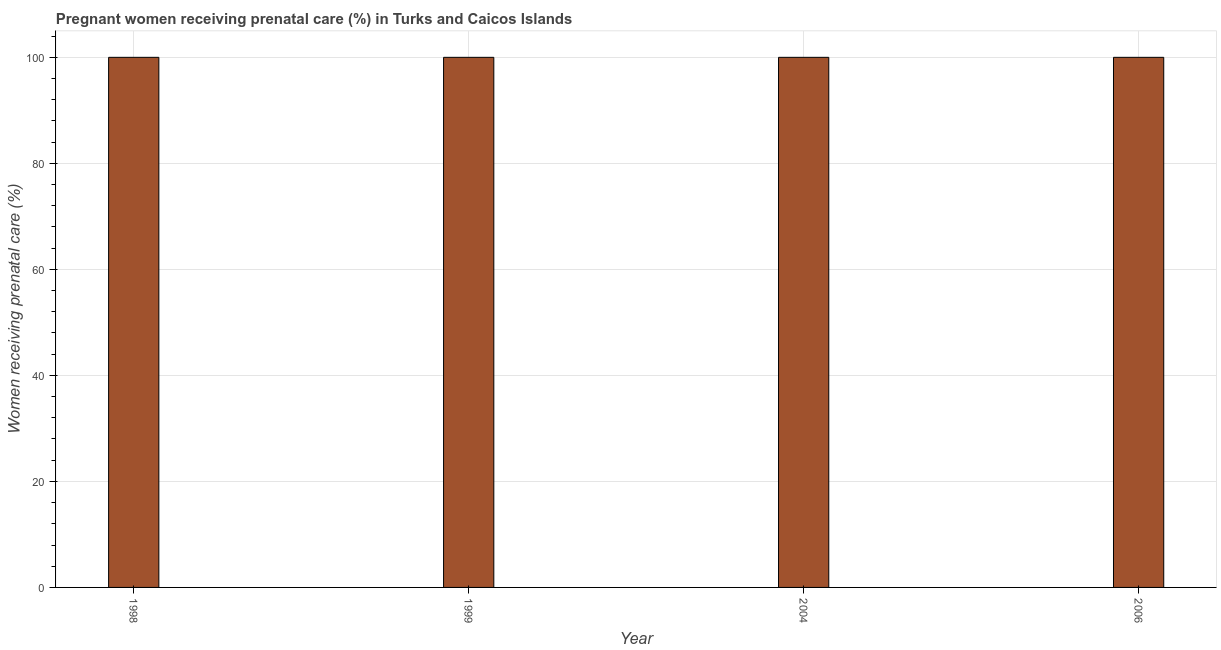Does the graph contain grids?
Provide a short and direct response. Yes. What is the title of the graph?
Make the answer very short. Pregnant women receiving prenatal care (%) in Turks and Caicos Islands. What is the label or title of the Y-axis?
Provide a short and direct response. Women receiving prenatal care (%). What is the percentage of pregnant women receiving prenatal care in 2004?
Keep it short and to the point. 100. Across all years, what is the maximum percentage of pregnant women receiving prenatal care?
Provide a short and direct response. 100. In which year was the percentage of pregnant women receiving prenatal care minimum?
Make the answer very short. 1998. What is the sum of the percentage of pregnant women receiving prenatal care?
Ensure brevity in your answer.  400. What is the average percentage of pregnant women receiving prenatal care per year?
Give a very brief answer. 100. What is the median percentage of pregnant women receiving prenatal care?
Your answer should be very brief. 100. In how many years, is the percentage of pregnant women receiving prenatal care greater than 96 %?
Make the answer very short. 4. Do a majority of the years between 1998 and 2004 (inclusive) have percentage of pregnant women receiving prenatal care greater than 72 %?
Offer a terse response. Yes. Is the percentage of pregnant women receiving prenatal care in 2004 less than that in 2006?
Provide a succinct answer. No. Is the difference between the percentage of pregnant women receiving prenatal care in 1998 and 1999 greater than the difference between any two years?
Provide a short and direct response. Yes. What is the difference between the highest and the second highest percentage of pregnant women receiving prenatal care?
Your response must be concise. 0. Is the sum of the percentage of pregnant women receiving prenatal care in 1998 and 1999 greater than the maximum percentage of pregnant women receiving prenatal care across all years?
Provide a short and direct response. Yes. Are all the bars in the graph horizontal?
Your answer should be compact. No. What is the difference between two consecutive major ticks on the Y-axis?
Your answer should be very brief. 20. Are the values on the major ticks of Y-axis written in scientific E-notation?
Offer a very short reply. No. What is the Women receiving prenatal care (%) in 1999?
Provide a succinct answer. 100. What is the Women receiving prenatal care (%) of 2006?
Provide a short and direct response. 100. What is the difference between the Women receiving prenatal care (%) in 1998 and 1999?
Offer a very short reply. 0. What is the difference between the Women receiving prenatal care (%) in 1998 and 2006?
Your answer should be compact. 0. What is the difference between the Women receiving prenatal care (%) in 1999 and 2006?
Offer a very short reply. 0. What is the difference between the Women receiving prenatal care (%) in 2004 and 2006?
Provide a succinct answer. 0. What is the ratio of the Women receiving prenatal care (%) in 1998 to that in 1999?
Give a very brief answer. 1. What is the ratio of the Women receiving prenatal care (%) in 1998 to that in 2004?
Your response must be concise. 1. What is the ratio of the Women receiving prenatal care (%) in 1999 to that in 2004?
Ensure brevity in your answer.  1. What is the ratio of the Women receiving prenatal care (%) in 1999 to that in 2006?
Offer a very short reply. 1. 